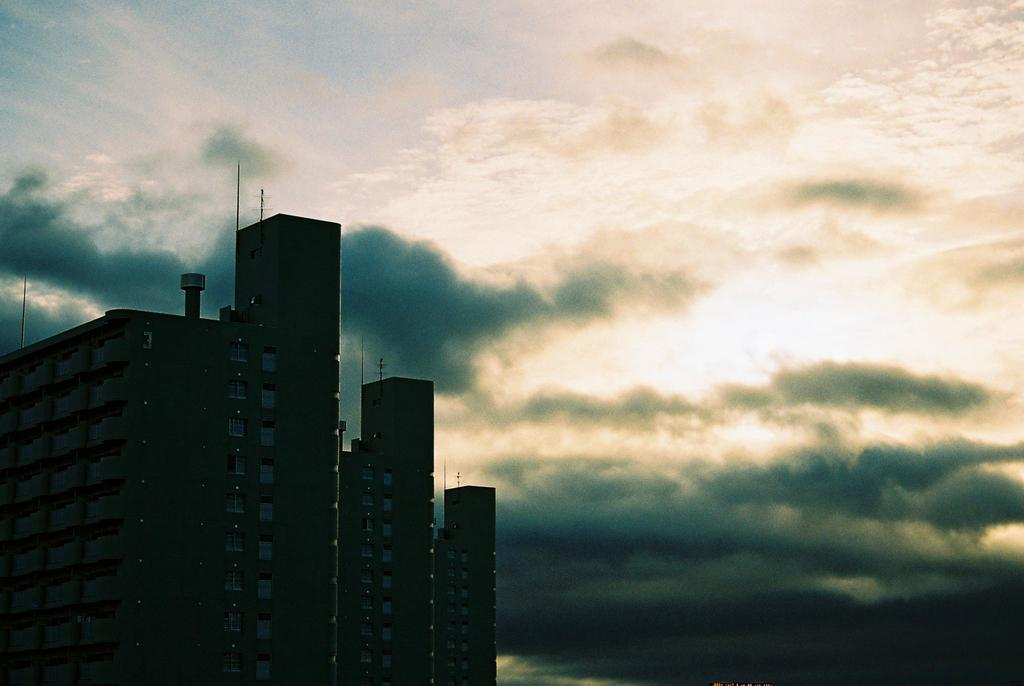What structure is located on the left side of the image? There is a building on the left side of the image. What features can be seen on the building? The building has windows and pillars. What else is present in the image besides the building? There are poles in the image. What is visible in the background of the image? The sky is visible in the background of the image. How would you describe the sky in the image? The sky is cloudy in the image. How many giants are holding the building in the image? There are no giants present in the image, and therefore none are holding the building. What advice does your uncle give about the building in the image? There is no mention of an uncle or any advice in the image, as it only shows a building, poles, and a cloudy sky. 